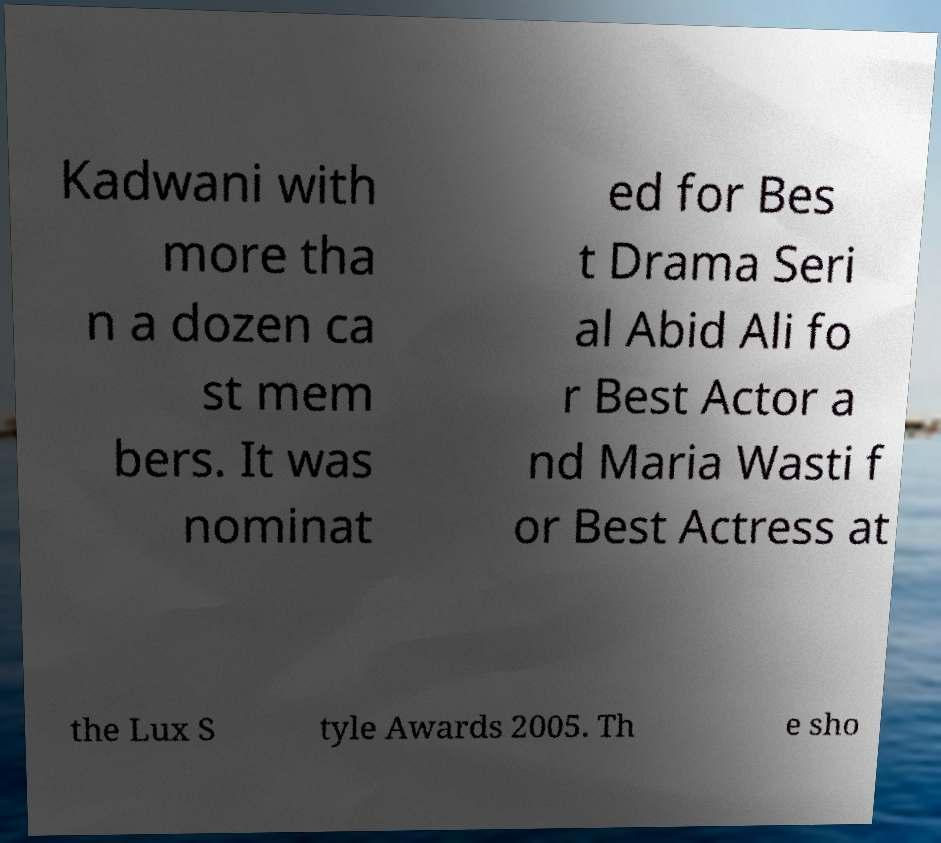There's text embedded in this image that I need extracted. Can you transcribe it verbatim? Kadwani with more tha n a dozen ca st mem bers. It was nominat ed for Bes t Drama Seri al Abid Ali fo r Best Actor a nd Maria Wasti f or Best Actress at the Lux S tyle Awards 2005. Th e sho 